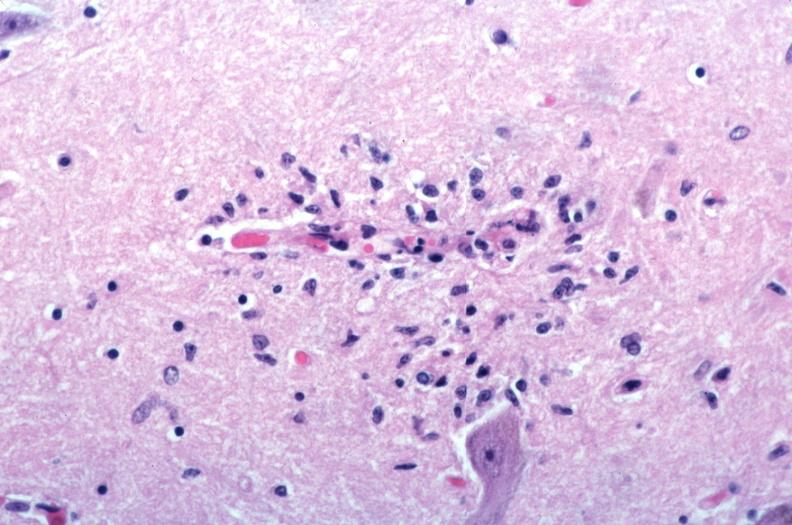s hemochromatosis spotted fever?
Answer the question using a single word or phrase. No 